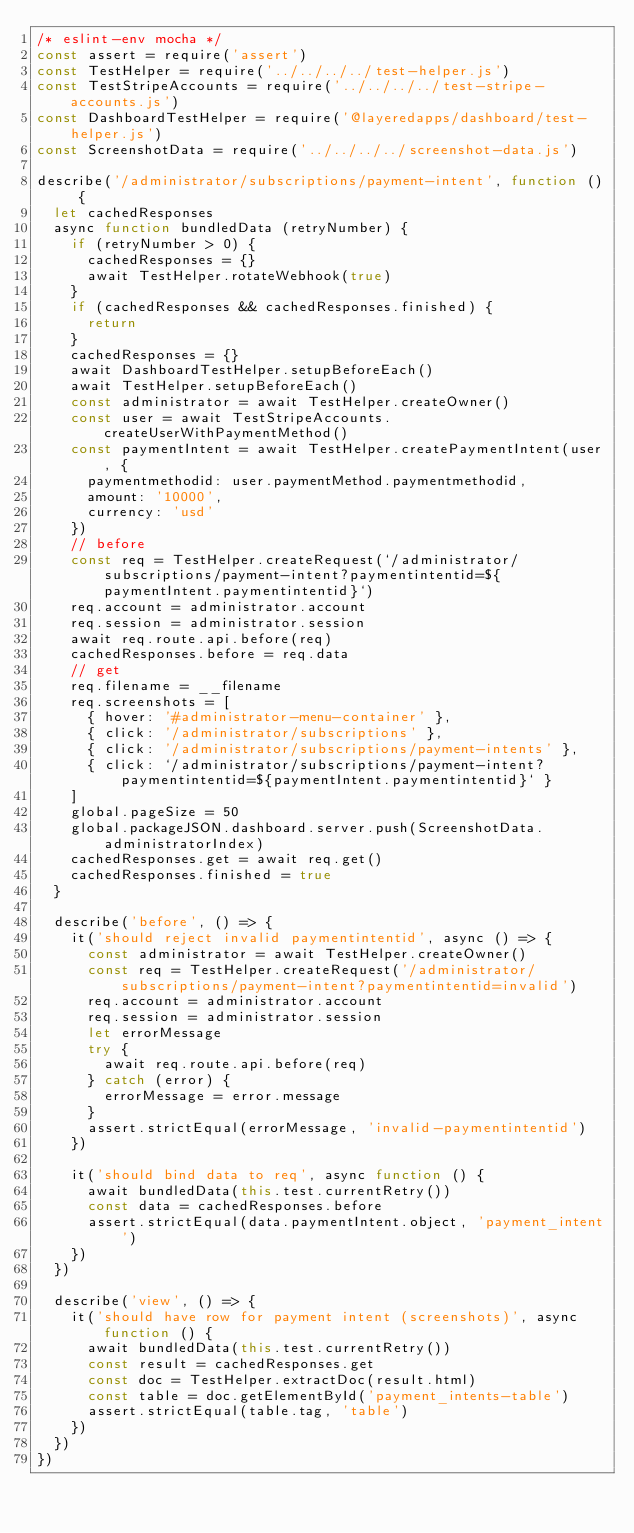Convert code to text. <code><loc_0><loc_0><loc_500><loc_500><_JavaScript_>/* eslint-env mocha */
const assert = require('assert')
const TestHelper = require('../../../../test-helper.js')
const TestStripeAccounts = require('../../../../test-stripe-accounts.js')
const DashboardTestHelper = require('@layeredapps/dashboard/test-helper.js')
const ScreenshotData = require('../../../../screenshot-data.js')

describe('/administrator/subscriptions/payment-intent', function () {
  let cachedResponses
  async function bundledData (retryNumber) {
    if (retryNumber > 0) {
      cachedResponses = {}
      await TestHelper.rotateWebhook(true)
    }
    if (cachedResponses && cachedResponses.finished) {
      return
    }
    cachedResponses = {}
    await DashboardTestHelper.setupBeforeEach()
    await TestHelper.setupBeforeEach()
    const administrator = await TestHelper.createOwner()
    const user = await TestStripeAccounts.createUserWithPaymentMethod()
    const paymentIntent = await TestHelper.createPaymentIntent(user, {
      paymentmethodid: user.paymentMethod.paymentmethodid,
      amount: '10000',
      currency: 'usd'
    })
    // before
    const req = TestHelper.createRequest(`/administrator/subscriptions/payment-intent?paymentintentid=${paymentIntent.paymentintentid}`)
    req.account = administrator.account
    req.session = administrator.session
    await req.route.api.before(req)
    cachedResponses.before = req.data
    // get
    req.filename = __filename
    req.screenshots = [
      { hover: '#administrator-menu-container' },
      { click: '/administrator/subscriptions' },
      { click: '/administrator/subscriptions/payment-intents' },
      { click: `/administrator/subscriptions/payment-intent?paymentintentid=${paymentIntent.paymentintentid}` }
    ]
    global.pageSize = 50
    global.packageJSON.dashboard.server.push(ScreenshotData.administratorIndex)
    cachedResponses.get = await req.get()
    cachedResponses.finished = true
  }

  describe('before', () => {
    it('should reject invalid paymentintentid', async () => {
      const administrator = await TestHelper.createOwner()
      const req = TestHelper.createRequest('/administrator/subscriptions/payment-intent?paymentintentid=invalid')
      req.account = administrator.account
      req.session = administrator.session
      let errorMessage
      try {
        await req.route.api.before(req)
      } catch (error) {
        errorMessage = error.message
      }
      assert.strictEqual(errorMessage, 'invalid-paymentintentid')
    })

    it('should bind data to req', async function () {
      await bundledData(this.test.currentRetry())
      const data = cachedResponses.before
      assert.strictEqual(data.paymentIntent.object, 'payment_intent')
    })
  })

  describe('view', () => {
    it('should have row for payment intent (screenshots)', async function () {
      await bundledData(this.test.currentRetry())
      const result = cachedResponses.get
      const doc = TestHelper.extractDoc(result.html)
      const table = doc.getElementById('payment_intents-table')
      assert.strictEqual(table.tag, 'table')
    })
  })
})
</code> 